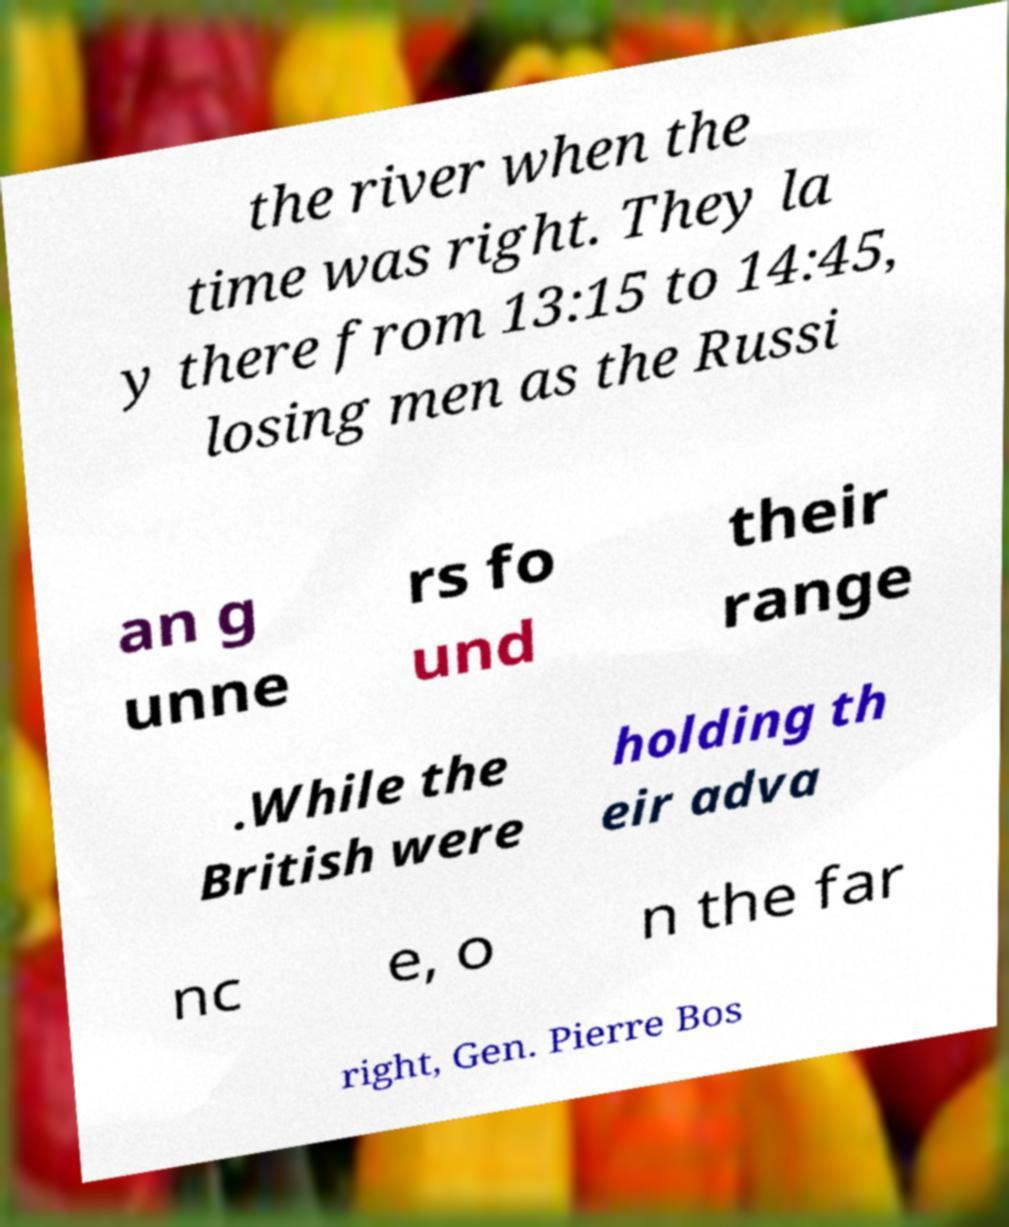What messages or text are displayed in this image? I need them in a readable, typed format. the river when the time was right. They la y there from 13:15 to 14:45, losing men as the Russi an g unne rs fo und their range .While the British were holding th eir adva nc e, o n the far right, Gen. Pierre Bos 